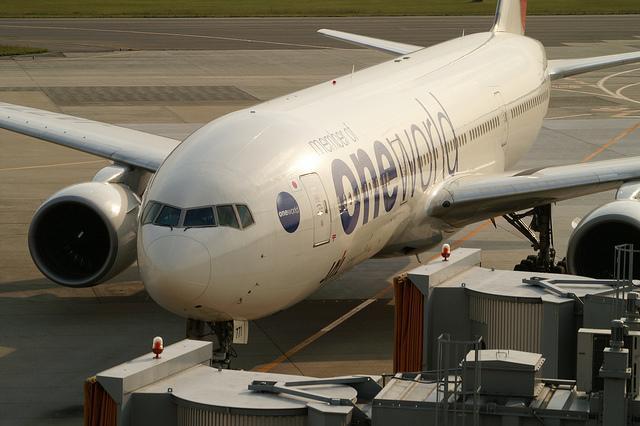How many people wearing a white cap are there?
Give a very brief answer. 0. 